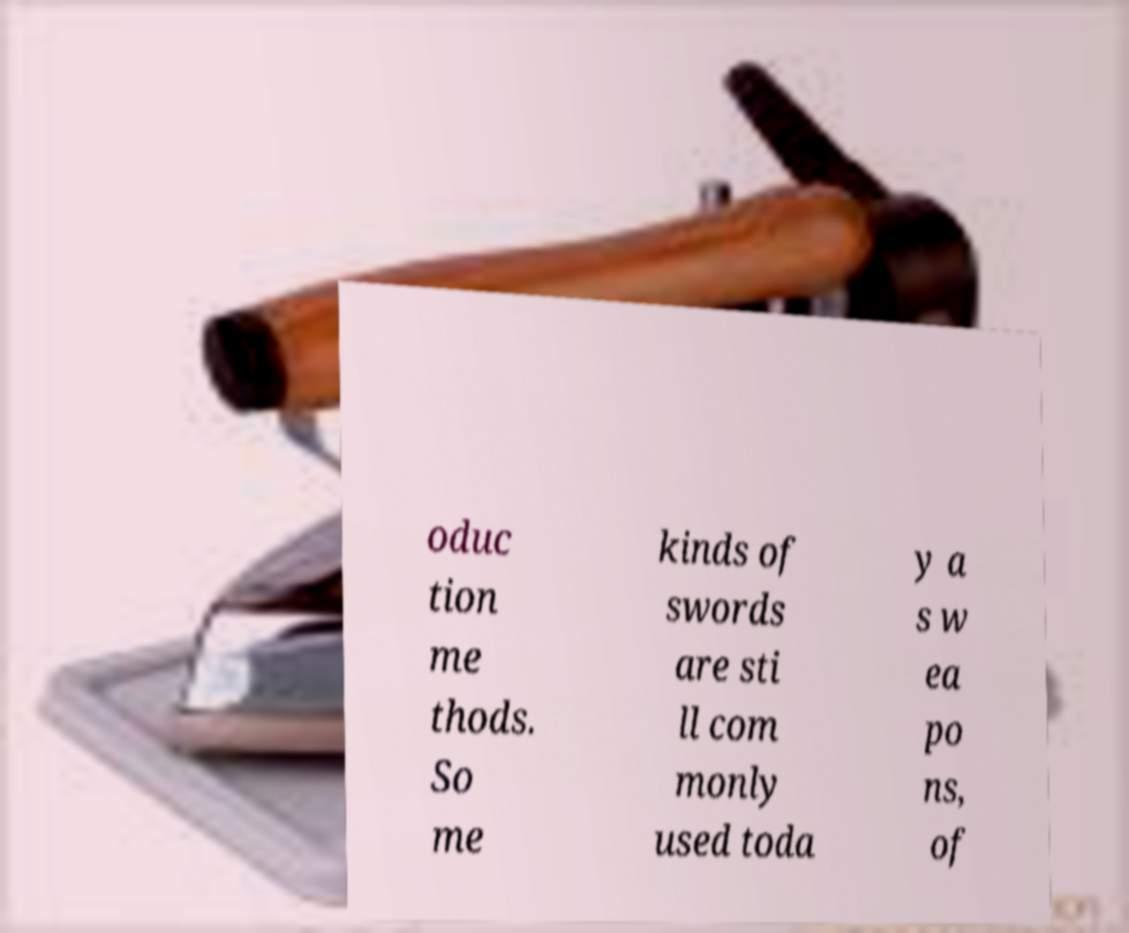Could you extract and type out the text from this image? oduc tion me thods. So me kinds of swords are sti ll com monly used toda y a s w ea po ns, of 